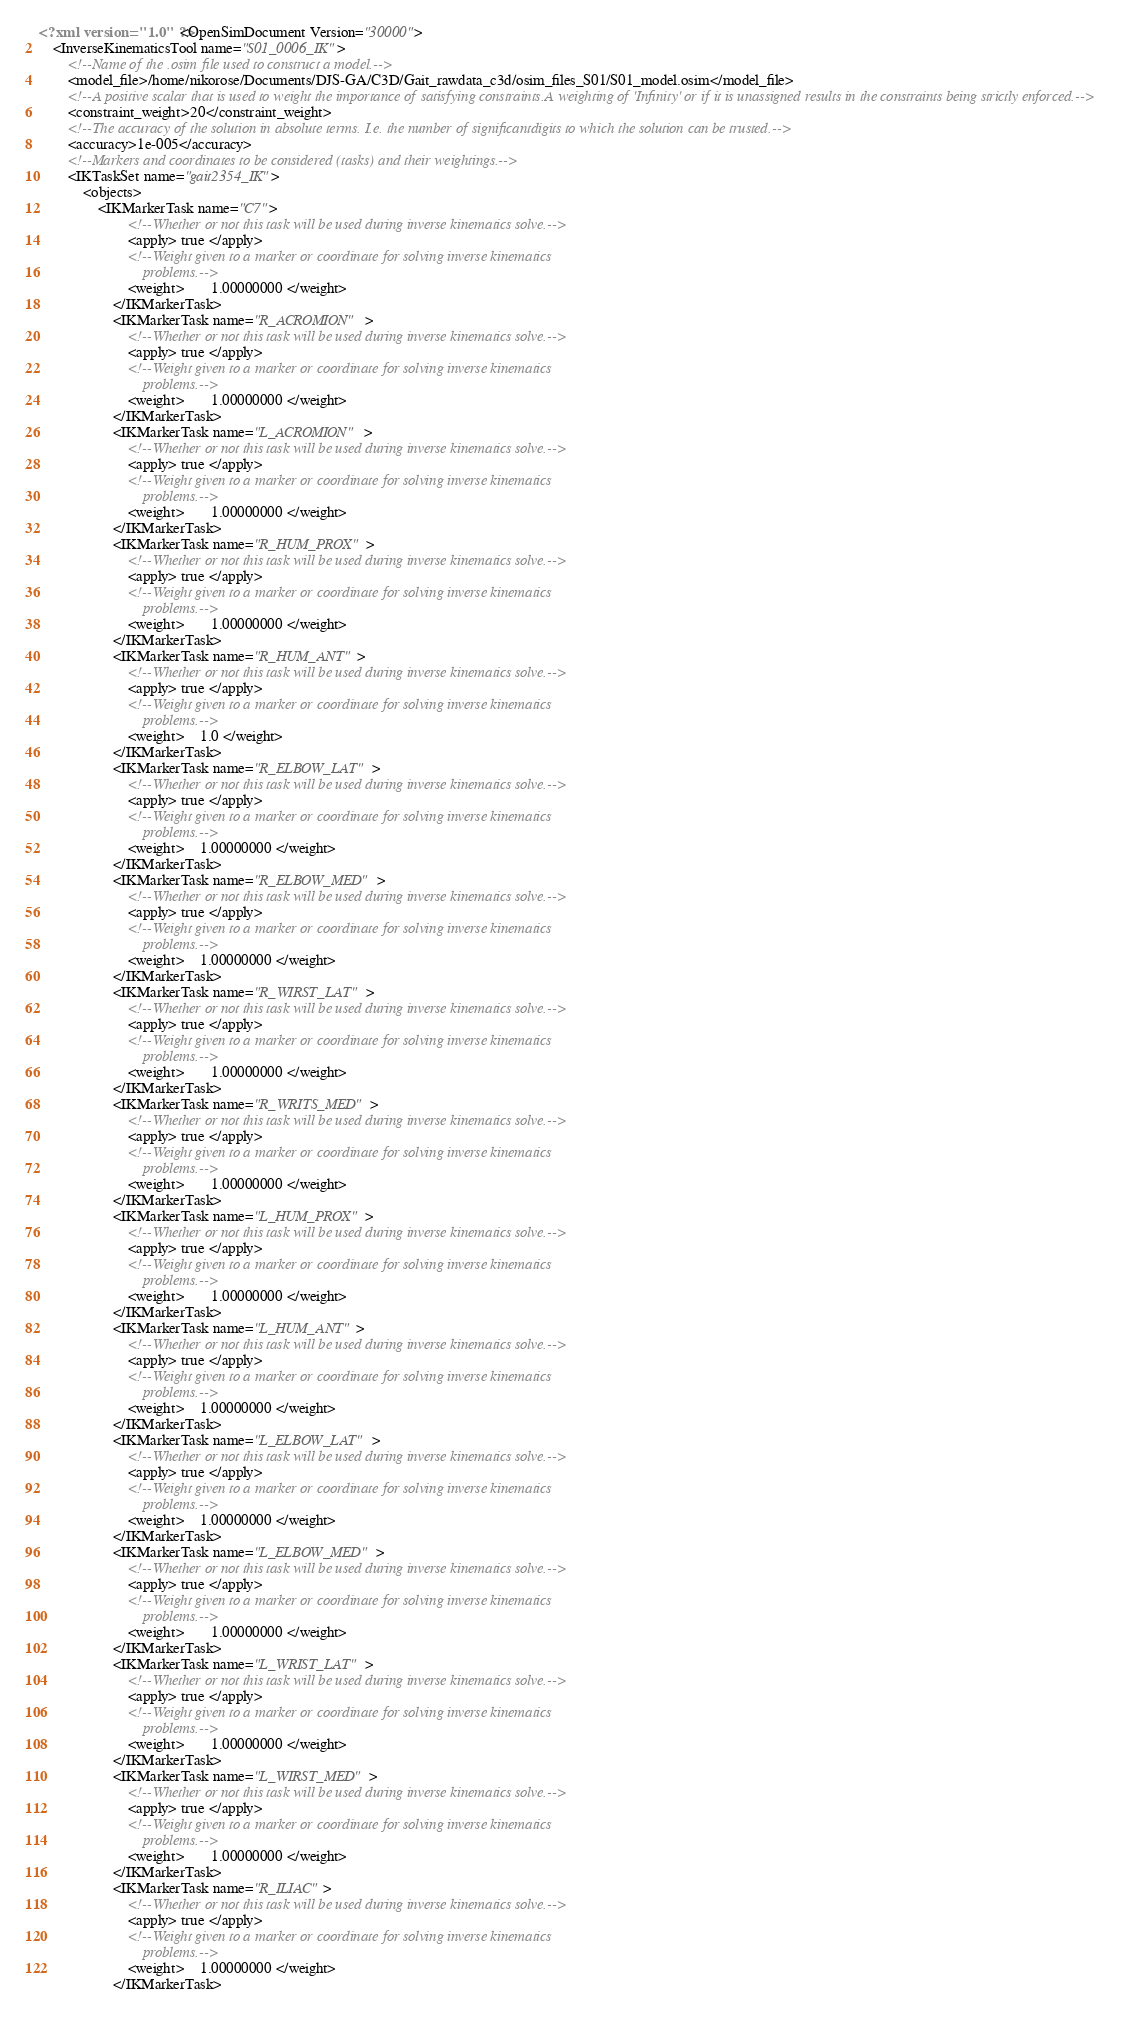<code> <loc_0><loc_0><loc_500><loc_500><_XML_><?xml version="1.0" ?><OpenSimDocument Version="30000">
	<InverseKinematicsTool name="S01_0006_IK">
		<!--Name of the .osim file used to construct a model.-->
		<model_file>/home/nikorose/Documents/DJS-GA/C3D/Gait_rawdata_c3d/osim_files_S01/S01_model.osim</model_file>
		<!--A positive scalar that is used to weight the importance of satisfying constraints.A weighting of 'Infinity' or if it is unassigned results in the constraints being strictly enforced.-->
		<constraint_weight>20</constraint_weight>
		<!--The accuracy of the solution in absolute terms. I.e. the number of significantdigits to which the solution can be trusted.-->
		<accuracy>1e-005</accuracy>
		<!--Markers and coordinates to be considered (tasks) and their weightings.-->
		<IKTaskSet name="gait2354_IK">
			<objects>
				<IKMarkerTask name="C7">
						<!--Whether or not this task will be used during inverse kinematics solve.-->
						<apply> true </apply>
						<!--Weight given to a marker or coordinate for solving inverse kinematics
						    problems.-->
						<weight>       1.00000000 </weight>
					</IKMarkerTask>
					<IKMarkerTask name="R_ACROMION">
						<!--Whether or not this task will be used during inverse kinematics solve.-->
						<apply> true </apply>
						<!--Weight given to a marker or coordinate for solving inverse kinematics
						    problems.-->
						<weight>       1.00000000 </weight>
					</IKMarkerTask>
					<IKMarkerTask name="L_ACROMION">
						<!--Whether or not this task will be used during inverse kinematics solve.-->
						<apply> true </apply>
						<!--Weight given to a marker or coordinate for solving inverse kinematics
						    problems.-->
						<weight>       1.00000000 </weight>
					</IKMarkerTask>
					<IKMarkerTask name="R_HUM_PROX">
						<!--Whether or not this task will be used during inverse kinematics solve.-->
						<apply> true </apply>
						<!--Weight given to a marker or coordinate for solving inverse kinematics
						    problems.-->
						<weight>       1.00000000 </weight>
					</IKMarkerTask>
					<IKMarkerTask name="R_HUM_ANT">
						<!--Whether or not this task will be used during inverse kinematics solve.-->
						<apply> true </apply>
						<!--Weight given to a marker or coordinate for solving inverse kinematics
						    problems.-->
						<weight>    1.0 </weight>
					</IKMarkerTask>
					<IKMarkerTask name="R_ELBOW_LAT">
						<!--Whether or not this task will be used during inverse kinematics solve.-->
						<apply> true </apply>
						<!--Weight given to a marker or coordinate for solving inverse kinematics
						    problems.-->
						<weight>    1.00000000 </weight>
					</IKMarkerTask>
					<IKMarkerTask name="R_ELBOW_MED">
						<!--Whether or not this task will be used during inverse kinematics solve.-->
						<apply> true </apply>
						<!--Weight given to a marker or coordinate for solving inverse kinematics
						    problems.-->
						<weight>    1.00000000 </weight>
					</IKMarkerTask>
					<IKMarkerTask name="R_WIRST_LAT">
						<!--Whether or not this task will be used during inverse kinematics solve.-->
						<apply> true </apply>
						<!--Weight given to a marker or coordinate for solving inverse kinematics
						    problems.-->
						<weight>       1.00000000 </weight>
					</IKMarkerTask>
					<IKMarkerTask name="R_WRITS_MED">
						<!--Whether or not this task will be used during inverse kinematics solve.-->
						<apply> true </apply>
						<!--Weight given to a marker or coordinate for solving inverse kinematics
						    problems.-->
						<weight>       1.00000000 </weight>
					</IKMarkerTask>
					<IKMarkerTask name="L_HUM_PROX">
						<!--Whether or not this task will be used during inverse kinematics solve.-->
						<apply> true </apply>
						<!--Weight given to a marker or coordinate for solving inverse kinematics
						    problems.-->
						<weight>       1.00000000 </weight>
					</IKMarkerTask>
					<IKMarkerTask name="L_HUM_ANT">
						<!--Whether or not this task will be used during inverse kinematics solve.-->
						<apply> true </apply>
						<!--Weight given to a marker or coordinate for solving inverse kinematics
						    problems.-->
						<weight>    1.00000000 </weight>
					</IKMarkerTask>
					<IKMarkerTask name="L_ELBOW_LAT">
						<!--Whether or not this task will be used during inverse kinematics solve.-->
						<apply> true </apply>
						<!--Weight given to a marker or coordinate for solving inverse kinematics
						    problems.-->
						<weight>    1.00000000 </weight>
					</IKMarkerTask>
					<IKMarkerTask name="L_ELBOW_MED">
						<!--Whether or not this task will be used during inverse kinematics solve.-->
						<apply> true </apply>
						<!--Weight given to a marker or coordinate for solving inverse kinematics
						    problems.-->
						<weight>       1.00000000 </weight>
					</IKMarkerTask>
					<IKMarkerTask name="L_WRIST_LAT">
						<!--Whether or not this task will be used during inverse kinematics solve.-->
						<apply> true </apply>
						<!--Weight given to a marker or coordinate for solving inverse kinematics
						    problems.-->
						<weight>       1.00000000 </weight>
					</IKMarkerTask>
					<IKMarkerTask name="L_WIRST_MED">
						<!--Whether or not this task will be used during inverse kinematics solve.-->
						<apply> true </apply>
						<!--Weight given to a marker or coordinate for solving inverse kinematics
						    problems.-->
						<weight>       1.00000000 </weight>
					</IKMarkerTask>
					<IKMarkerTask name="R_ILIAC">
						<!--Whether or not this task will be used during inverse kinematics solve.-->
						<apply> true </apply>
						<!--Weight given to a marker or coordinate for solving inverse kinematics
						    problems.-->
						<weight>    1.00000000 </weight>
					</IKMarkerTask></code> 